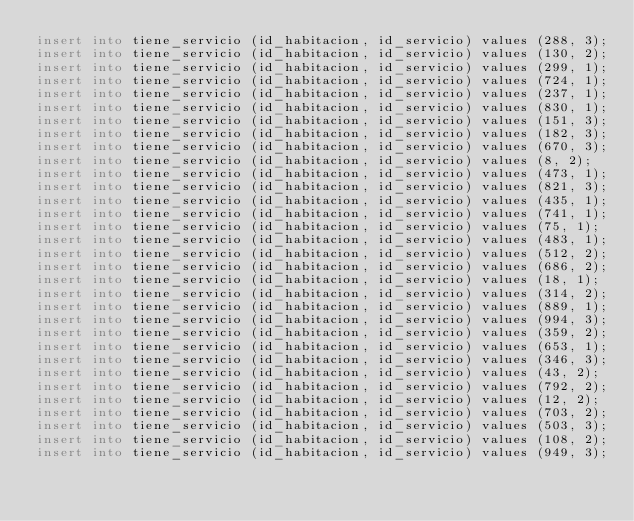Convert code to text. <code><loc_0><loc_0><loc_500><loc_500><_SQL_>insert into tiene_servicio (id_habitacion, id_servicio) values (288, 3);
insert into tiene_servicio (id_habitacion, id_servicio) values (130, 2);
insert into tiene_servicio (id_habitacion, id_servicio) values (299, 1);
insert into tiene_servicio (id_habitacion, id_servicio) values (724, 1);
insert into tiene_servicio (id_habitacion, id_servicio) values (237, 1);
insert into tiene_servicio (id_habitacion, id_servicio) values (830, 1);
insert into tiene_servicio (id_habitacion, id_servicio) values (151, 3);
insert into tiene_servicio (id_habitacion, id_servicio) values (182, 3);
insert into tiene_servicio (id_habitacion, id_servicio) values (670, 3);
insert into tiene_servicio (id_habitacion, id_servicio) values (8, 2);
insert into tiene_servicio (id_habitacion, id_servicio) values (473, 1);
insert into tiene_servicio (id_habitacion, id_servicio) values (821, 3);
insert into tiene_servicio (id_habitacion, id_servicio) values (435, 1);
insert into tiene_servicio (id_habitacion, id_servicio) values (741, 1);
insert into tiene_servicio (id_habitacion, id_servicio) values (75, 1);
insert into tiene_servicio (id_habitacion, id_servicio) values (483, 1);
insert into tiene_servicio (id_habitacion, id_servicio) values (512, 2);
insert into tiene_servicio (id_habitacion, id_servicio) values (686, 2);
insert into tiene_servicio (id_habitacion, id_servicio) values (18, 1);
insert into tiene_servicio (id_habitacion, id_servicio) values (314, 2);
insert into tiene_servicio (id_habitacion, id_servicio) values (889, 1);
insert into tiene_servicio (id_habitacion, id_servicio) values (994, 3);
insert into tiene_servicio (id_habitacion, id_servicio) values (359, 2);
insert into tiene_servicio (id_habitacion, id_servicio) values (653, 1);
insert into tiene_servicio (id_habitacion, id_servicio) values (346, 3);
insert into tiene_servicio (id_habitacion, id_servicio) values (43, 2);
insert into tiene_servicio (id_habitacion, id_servicio) values (792, 2);
insert into tiene_servicio (id_habitacion, id_servicio) values (12, 2);
insert into tiene_servicio (id_habitacion, id_servicio) values (703, 2);
insert into tiene_servicio (id_habitacion, id_servicio) values (503, 3);
insert into tiene_servicio (id_habitacion, id_servicio) values (108, 2);
insert into tiene_servicio (id_habitacion, id_servicio) values (949, 3);</code> 